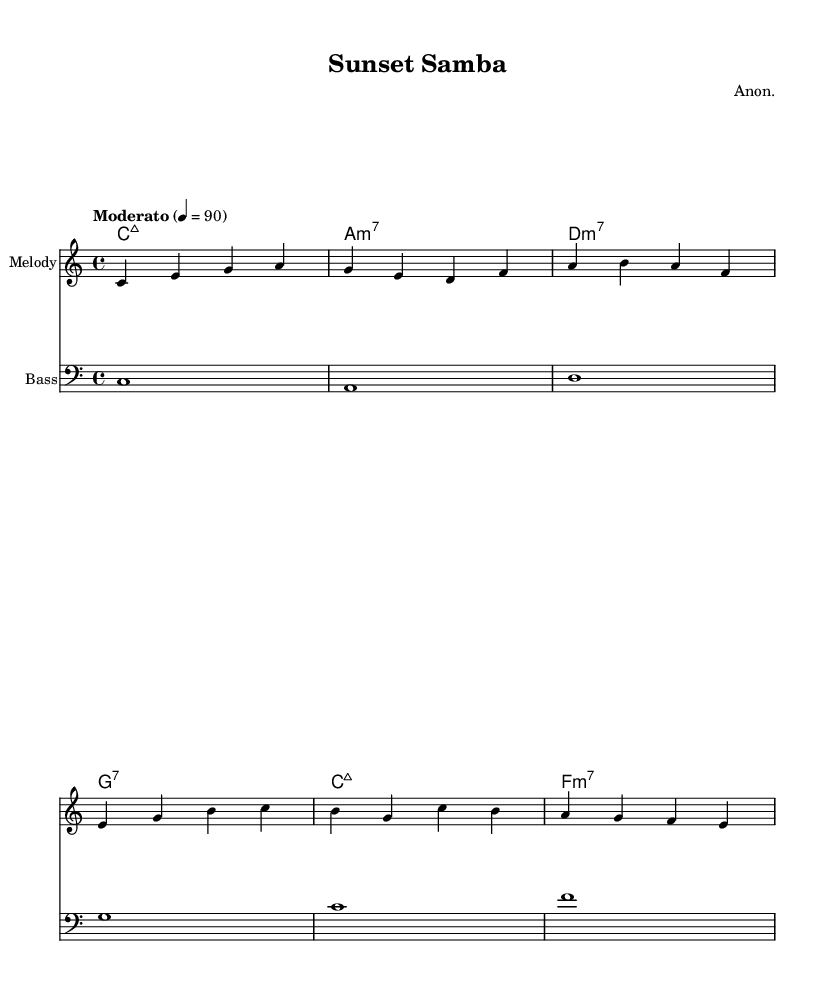What is the key signature of this music? The key signature is C major, which has no sharps or flats.
Answer: C major What is the time signature of this piece? The time signature shown at the beginning of the score is 4/4, indicating four beats per measure.
Answer: 4/4 What is the tempo marking for this song? The tempo marking indicates "Moderato" at a speed of 90 beats per minute.
Answer: Moderato 90 What type of seventh chord is used in the first measure of harmonies? The first chord indicated is a major seventh chord, which is denoted as "C:maj7."
Answer: Major seventh Which instrument is indicated for the melody? The score indicates that the staff labeled "Melody" is intended for a melodic instrument, typically a voice or lead instrument, but the specific instrument is not listed.
Answer: Melody How many measures are in the melody section provided? By counting the individual groups divided by the vertical lines, there are a total of 8 measures in the melody section.
Answer: 8 What theme is presented in the lyrics of the piece? The lyrics explore themes of unwinding and relaxation, reflecting the mood of retirement and tranquility.
Answer: Relaxation 